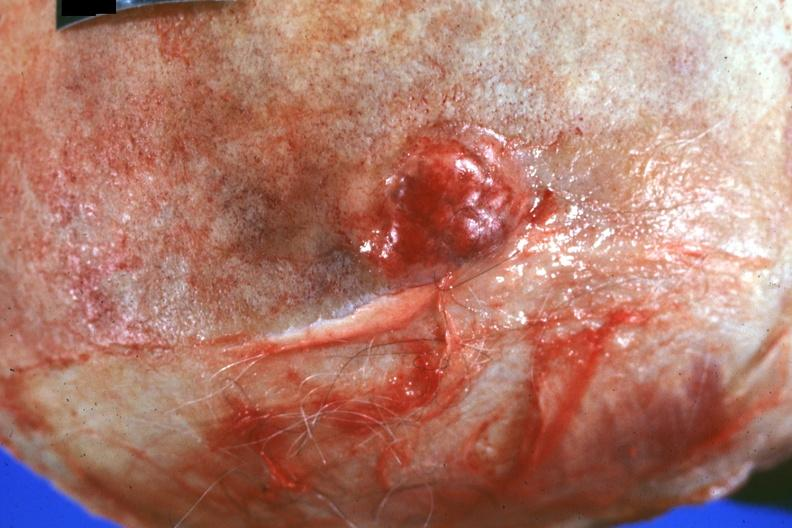s stein leventhal present?
Answer the question using a single word or phrase. No 